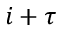<formula> <loc_0><loc_0><loc_500><loc_500>i + \tau</formula> 